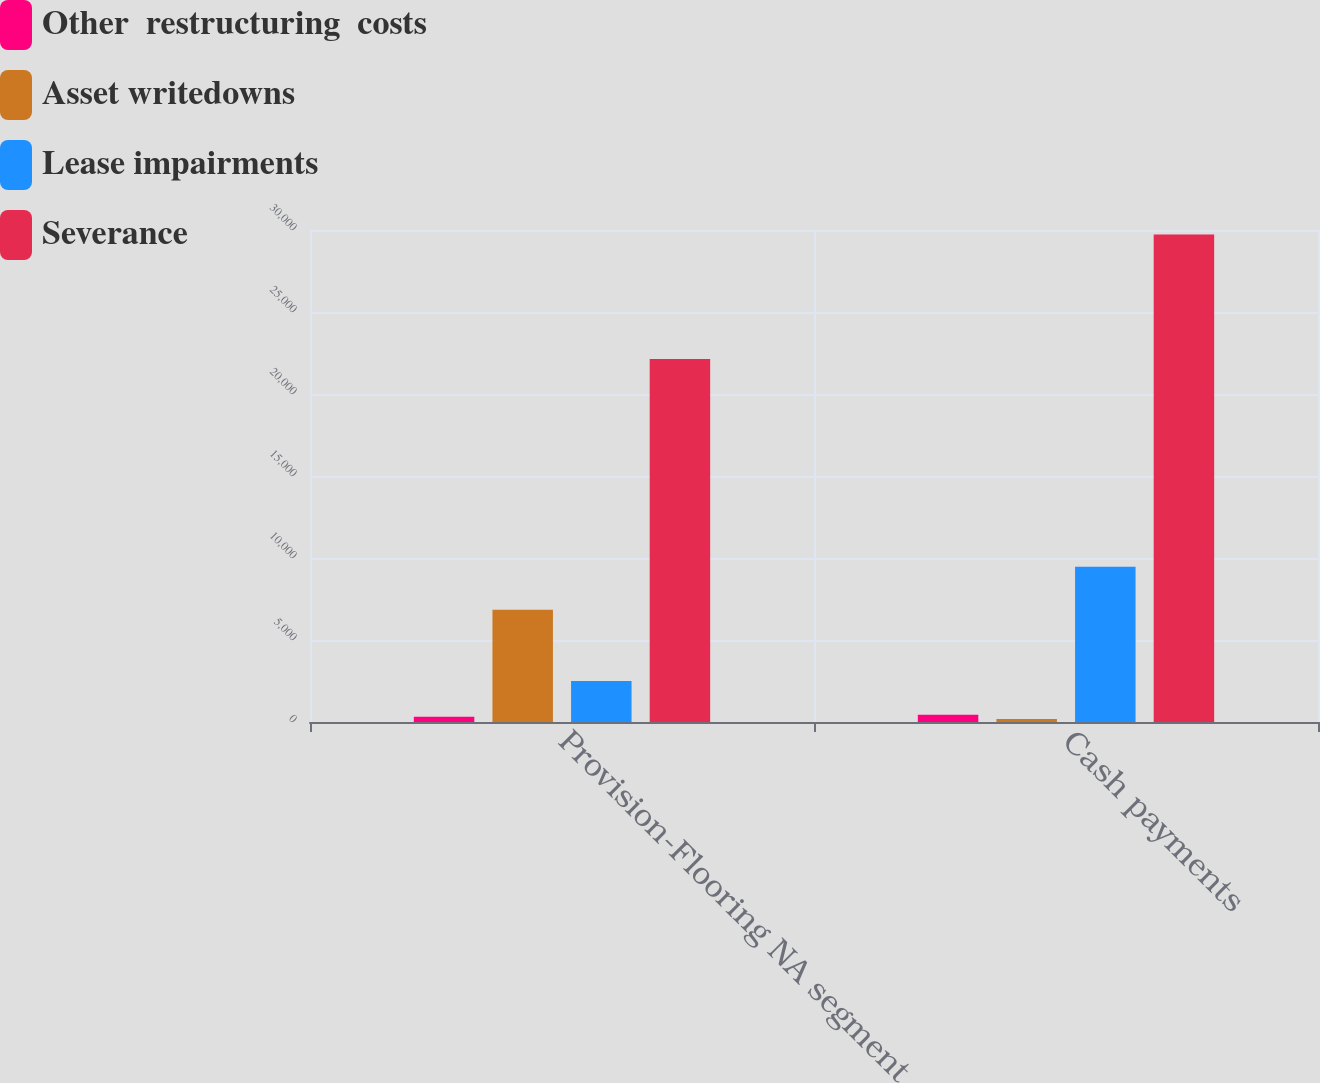Convert chart. <chart><loc_0><loc_0><loc_500><loc_500><stacked_bar_chart><ecel><fcel>Provision-Flooring NA segment<fcel>Cash payments<nl><fcel>Other  restructuring  costs<fcel>316<fcel>449<nl><fcel>Asset writedowns<fcel>6849<fcel>190<nl><fcel>Lease impairments<fcel>2500<fcel>9469<nl><fcel>Severance<fcel>22131<fcel>29725<nl></chart> 